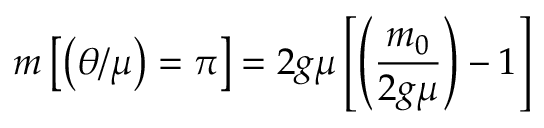<formula> <loc_0><loc_0><loc_500><loc_500>m \left [ \left ( \theta / \mu \right ) = \pi \right ] = 2 g \mu \left [ \left ( { \frac { m _ { 0 } } { 2 g \mu } } \right ) - 1 \right ]</formula> 